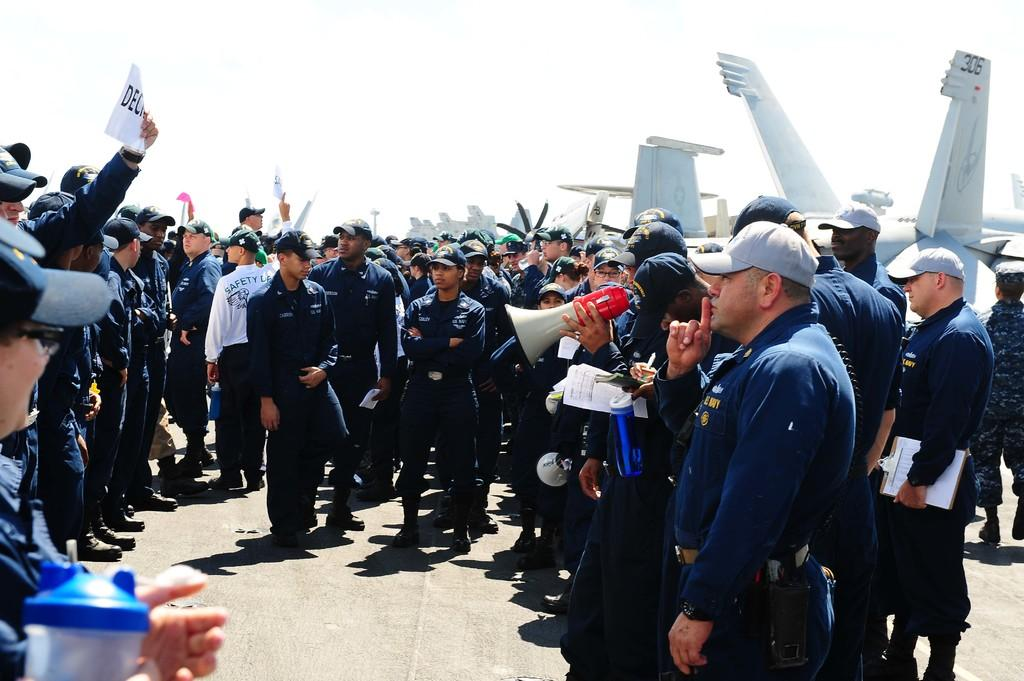What is happening with the group of people in the image? The group of people is on the ground in the image. What device is present for amplifying sound in the image? There is a loudspeaker in the image. What type of printed materials can be seen in the image? There are posters in the image. What other objects are visible in the image besides the people and posters? There are objects in the image. What can be seen in the distance in the background of the image? Airplanes are visible in the background of the image. What part of the natural environment is visible in the background of the image? The sky is visible in the background of the image. Where is the seashore located in the image? There is no seashore present in the image. What type of education is being provided at the event in the image? There is no indication of an educational event or activity in the image. 